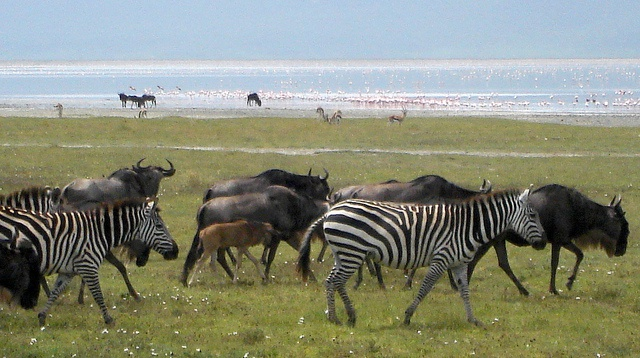Describe the objects in this image and their specific colors. I can see zebra in lavender, black, gray, darkgray, and darkgreen tones, zebra in lavender, black, gray, darkgray, and darkgreen tones, zebra in lavender, black, gray, darkgreen, and darkgray tones, bird in lightgray, darkgray, and lavender tones, and bird in lavender, lightgray, darkgray, and gray tones in this image. 